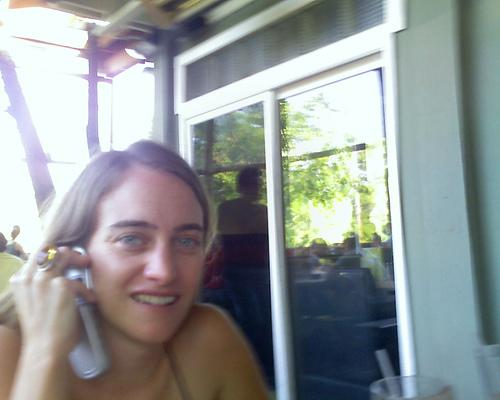Where is she most likely having a conversation on her cellphone? outside 